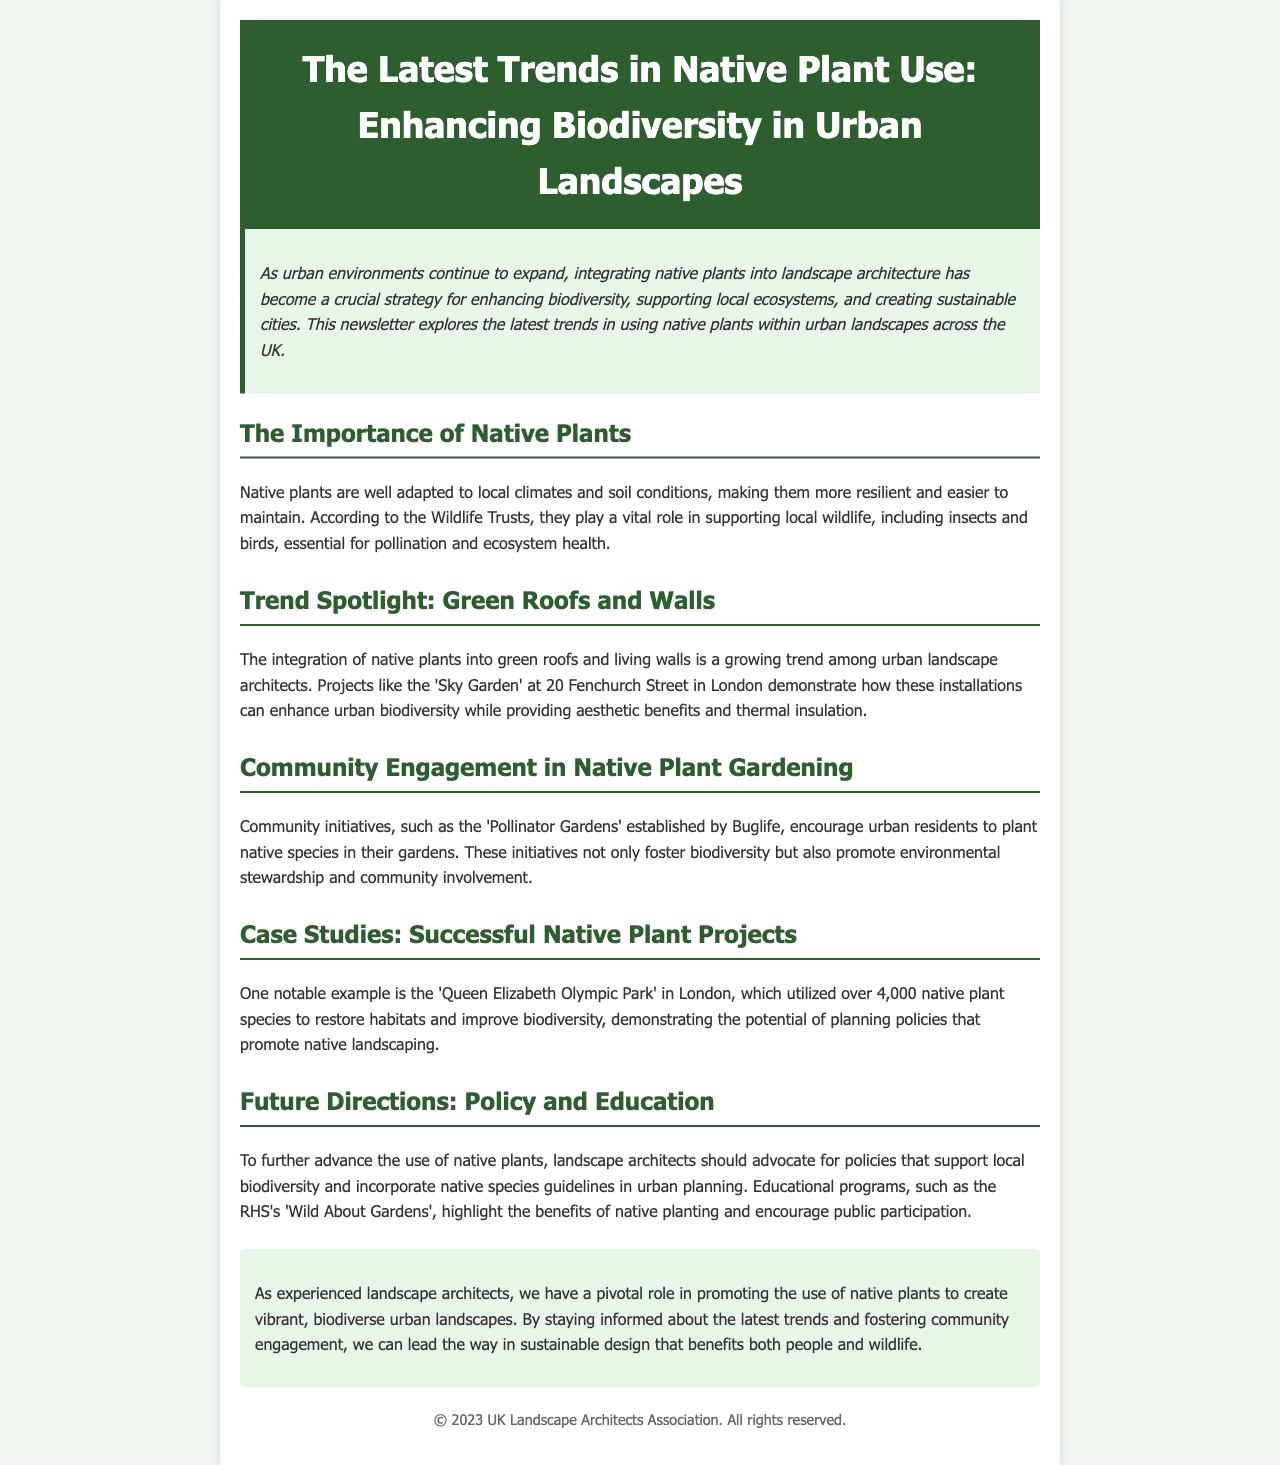What is the main theme of the newsletter? The main theme focuses on the integration of native plants in urban landscapes to enhance biodiversity and sustainability.
Answer: Enhancing biodiversity in urban landscapes How many native plant species were used in the Queen Elizabeth Olympic Park project? The document mentions that over 4,000 native plant species were utilized in the Queen Elizabeth Olympic Park project.
Answer: Over 4,000 What community initiative is mentioned for encouraging native species planting? The newsletter highlights the 'Pollinator Gardens' initiative established by Buglife, which encourages residents to plant native species.
Answer: Pollinator Gardens What type of green installations are being increasingly used by landscape architects? Landscape architects are increasingly integrating native plants into green roofs and living walls in urban settings.
Answer: Green roofs and walls Which organization conducted educational programs to promote native planting? The Royal Horticultural Society (RHS) is mentioned as conducting educational programs like 'Wild About Gardens' to promote native planting.
Answer: RHS What is a key benefit of native plants according to the Wildlife Trusts? Native plants are vital for supporting local wildlife, which is essential for pollination and ecosystem health, according to the Wildlife Trusts.
Answer: Supporting local wildlife What role do landscape architects have according to the conclusion of the newsletter? The conclusion states that experienced landscape architects have a pivotal role in promoting the use of native plants for sustainable urban design.
Answer: Promoting native plants What significant project is highlighted as a successful use of native plants? The 'Queen Elizabeth Olympic Park' is cited as a notable example of a successful native plant project in the document.
Answer: Queen Elizabeth Olympic Park What color is used for the document's header? The header background color of the document is a shade of green, specifically #2c5e2e.
Answer: Green 